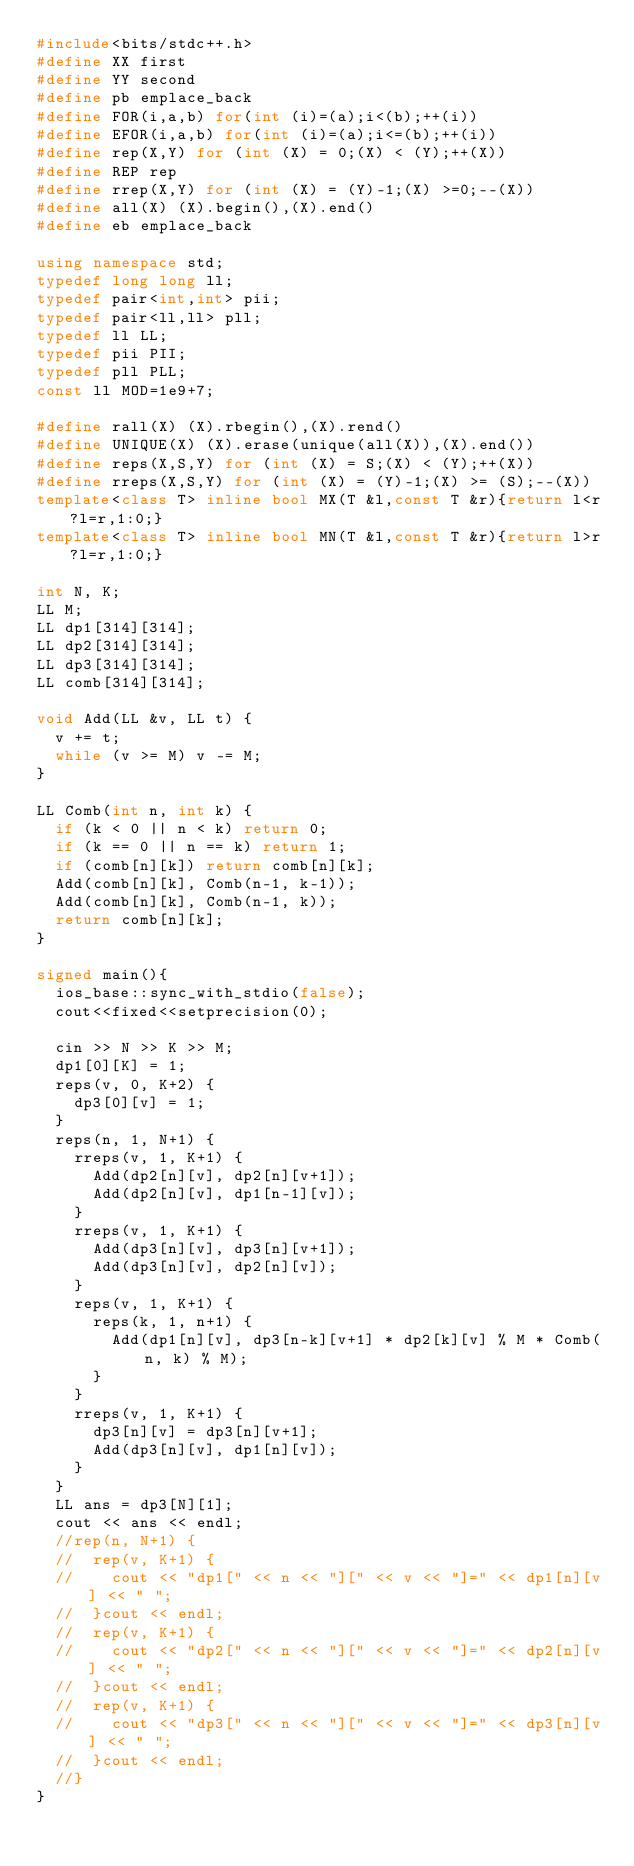Convert code to text. <code><loc_0><loc_0><loc_500><loc_500><_C++_>#include<bits/stdc++.h>
#define XX first
#define YY second
#define pb emplace_back
#define FOR(i,a,b) for(int (i)=(a);i<(b);++(i))
#define EFOR(i,a,b) for(int (i)=(a);i<=(b);++(i))
#define rep(X,Y) for (int (X) = 0;(X) < (Y);++(X))
#define REP rep
#define rrep(X,Y) for (int (X) = (Y)-1;(X) >=0;--(X))
#define all(X) (X).begin(),(X).end()
#define eb emplace_back

using namespace std;
typedef long long ll;
typedef pair<int,int> pii;
typedef pair<ll,ll> pll;
typedef ll LL;
typedef pii PII;
typedef pll PLL;
const ll MOD=1e9+7;

#define rall(X) (X).rbegin(),(X).rend()
#define UNIQUE(X) (X).erase(unique(all(X)),(X).end())
#define reps(X,S,Y) for (int (X) = S;(X) < (Y);++(X))
#define rreps(X,S,Y) for (int (X) = (Y)-1;(X) >= (S);--(X))
template<class T> inline bool MX(T &l,const T &r){return l<r?l=r,1:0;}
template<class T> inline bool MN(T &l,const T &r){return l>r?l=r,1:0;}

int N, K;
LL M;
LL dp1[314][314];
LL dp2[314][314];
LL dp3[314][314];
LL comb[314][314];

void Add(LL &v, LL t) {
  v += t;
  while (v >= M) v -= M;
}

LL Comb(int n, int k) {
  if (k < 0 || n < k) return 0;
  if (k == 0 || n == k) return 1;
  if (comb[n][k]) return comb[n][k];
  Add(comb[n][k], Comb(n-1, k-1));
  Add(comb[n][k], Comb(n-1, k));
  return comb[n][k];
}

signed main(){
  ios_base::sync_with_stdio(false);
  cout<<fixed<<setprecision(0);

  cin >> N >> K >> M;
  dp1[0][K] = 1;
  reps(v, 0, K+2) {
    dp3[0][v] = 1;
  }
  reps(n, 1, N+1) {
    rreps(v, 1, K+1) {
      Add(dp2[n][v], dp2[n][v+1]);
      Add(dp2[n][v], dp1[n-1][v]);
    }
    rreps(v, 1, K+1) {
      Add(dp3[n][v], dp3[n][v+1]);
      Add(dp3[n][v], dp2[n][v]);
    }
    reps(v, 1, K+1) {
      reps(k, 1, n+1) {
        Add(dp1[n][v], dp3[n-k][v+1] * dp2[k][v] % M * Comb(n, k) % M);
      }
    }
    rreps(v, 1, K+1) {
      dp3[n][v] = dp3[n][v+1];
      Add(dp3[n][v], dp1[n][v]);
    }
  }
  LL ans = dp3[N][1];
  cout << ans << endl;
  //rep(n, N+1) {
  //  rep(v, K+1) {
  //    cout << "dp1[" << n << "][" << v << "]=" << dp1[n][v] << " ";
  //  }cout << endl;
  //  rep(v, K+1) {
  //    cout << "dp2[" << n << "][" << v << "]=" << dp2[n][v] << " ";
  //  }cout << endl;
  //  rep(v, K+1) {
  //    cout << "dp3[" << n << "][" << v << "]=" << dp3[n][v] << " ";
  //  }cout << endl;
  //}
}
</code> 